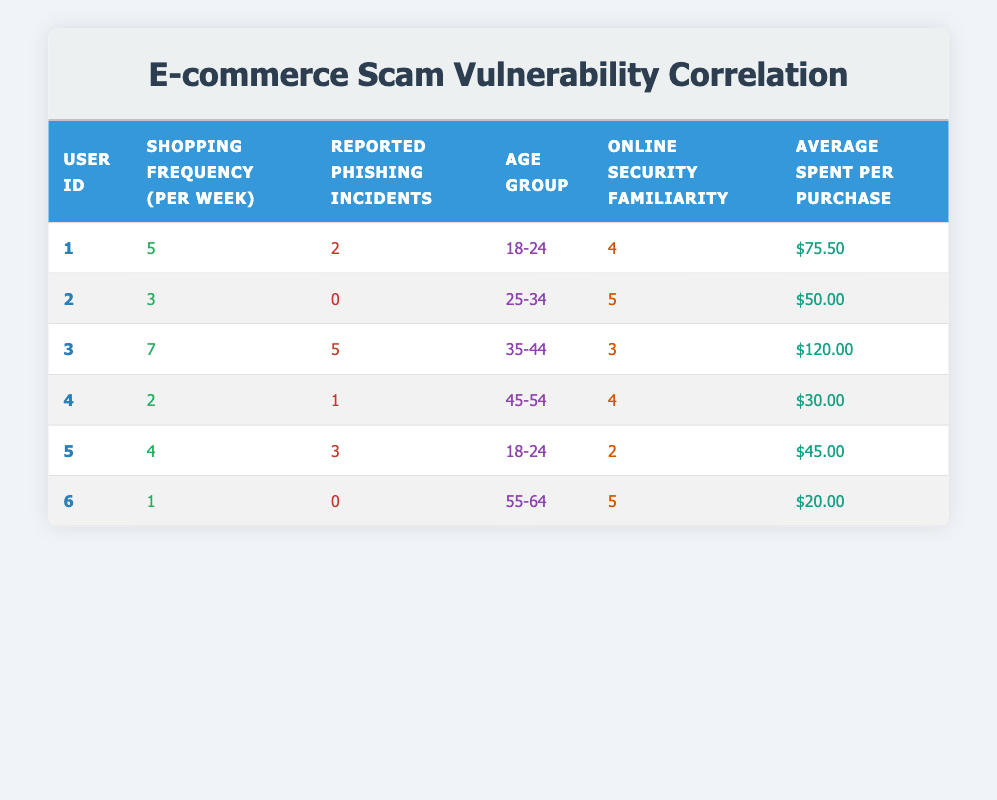What is the shopping frequency of user ID 3? User ID 3 has a shopping frequency of 7 per week as stated in the corresponding row.
Answer: 7 How many reported phishing incidents did user ID 2 have? According to the data for user ID 2, the reported phishing incidents are noted as 0.
Answer: 0 Which age group has the highest average spending per purchase? Calculate the average spending per purchase for each age group: 18-24: (75.50 + 45.00) / 2 = 60.25, 25-34: 50.00, 35-44: 120.00, 45-54: 30.00, 55-64: 20.00. The highest average is 120.00 from the 35-44 age group.
Answer: 35-44 Is there any user who reported phishing incidents despite having a high familiarity with online security? Analyzing the table, user ID 3 has a familiarity rating of 3 and reported 5 phishing incidents, which indicates that a user can still be vulnerable despite a lower familiarity score.
Answer: Yes What is the total number of reported phishing incidents across all users? Count all the reported phishing incidents: 2 + 0 + 5 + 1 + 3 + 0 = 11. Thus, the total number of reported incidents is 11.
Answer: 11 How many users have a shopping frequency of 4 or more times per week? By counting the users with shopping frequency 4 or more, we find user IDs: 1 (5), 3 (7), and 5 (4), which gives us a total of 3 users.
Answer: 3 What is the correlation between shopping frequency and reported phishing incidents? One way to analyze this is to see if higher shopping frequency generally leads to more phishing incidents. User ID 3 has the highest frequency with 7 and 5 phishing incidents, while user ID 2 has 3 frequency with 0 incidents. Analyzing further suggests no direct correlation since other users show different patterns.
Answer: No clear correlation Which user has the lowest average spending per purchase? User ID 6 has the lowest average spending, stated as 20.00.
Answer: 20.00 Is there a user who reported phishing incidents but has high familiarity with online security? User ID 3 has a familiarity of 3 yet reported 5 phishing incidents, showing that even users with moderate familiarity can be vulnerable.
Answer: Yes 